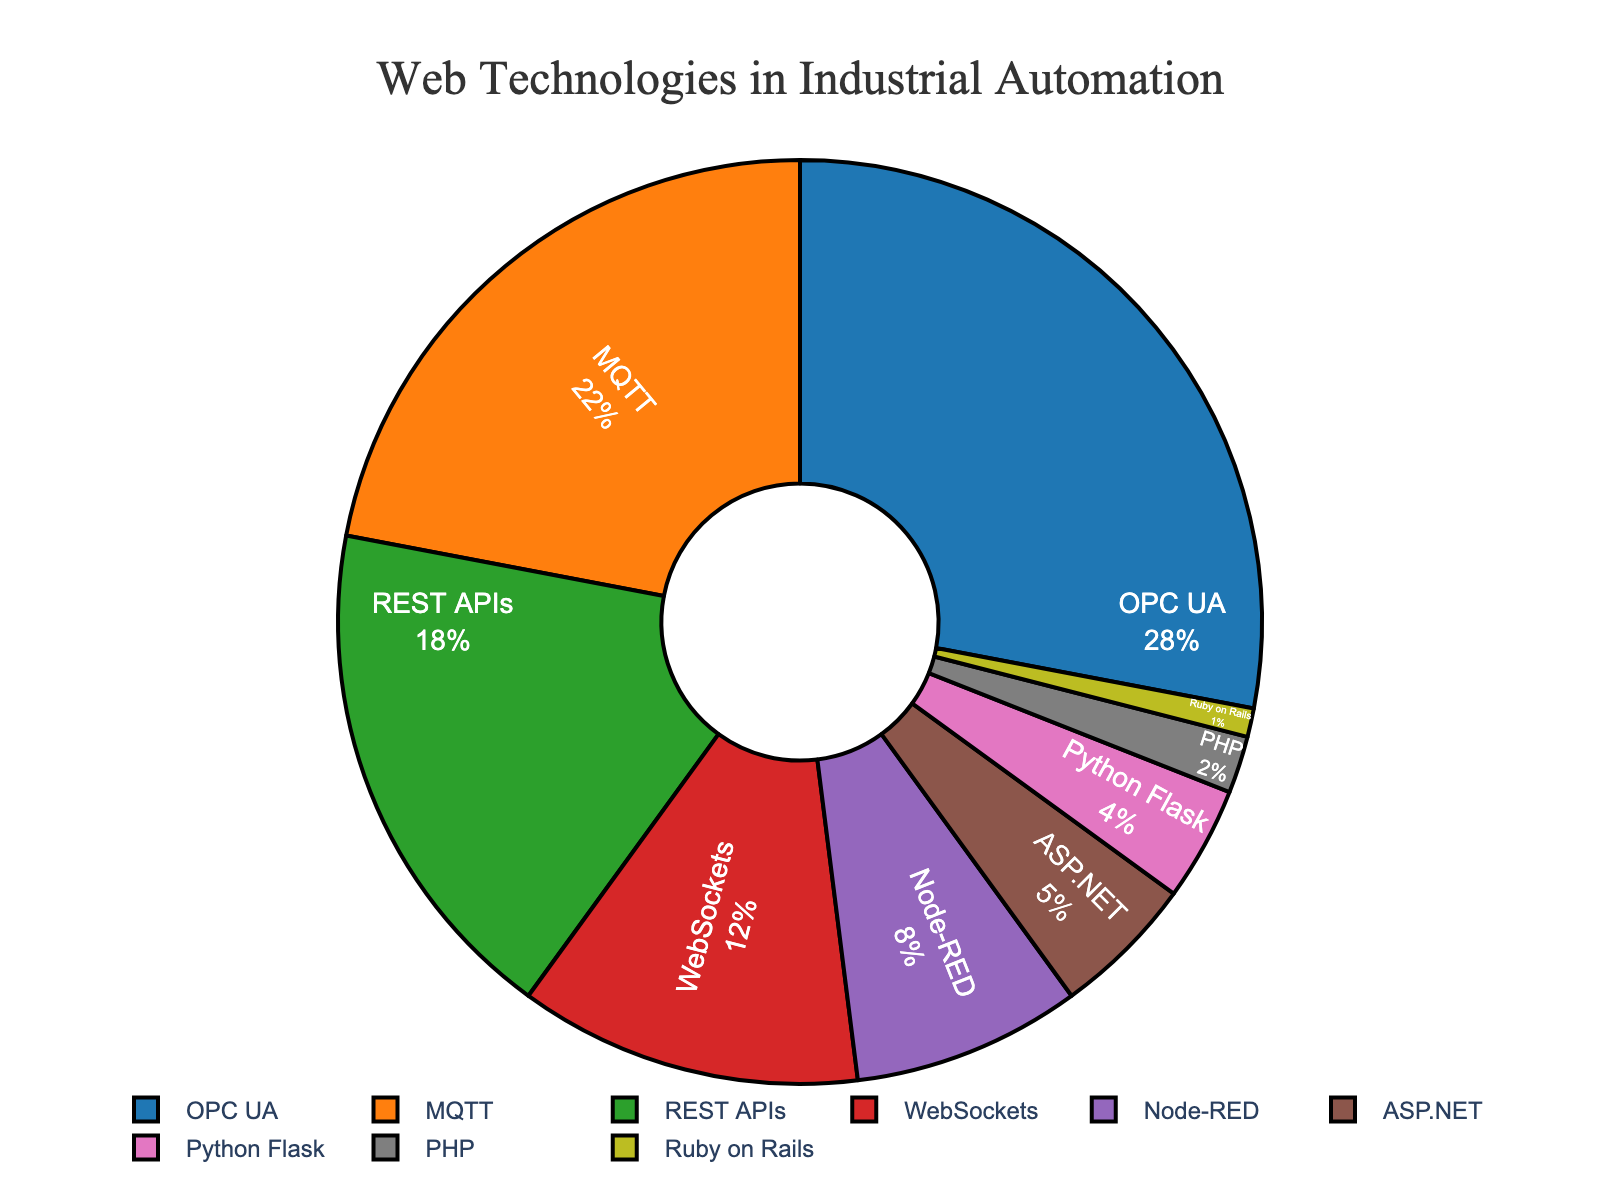What's the most adopted web technology in industrial automation? The pie chart shows that OPC UA has the largest segment, indicating it is the most adopted web technology.
Answer: OPC UA What is the combined adoption percentage of MQTT and REST APIs? According to the data, MQTT has an adoption percentage of 22%, and REST APIs have 18%. Adding these together, 22% + 18% = 40%.
Answer: 40% Which technology has a higher adoption rate: Node-RED or WebSockets? By comparing the segments, WebSockets have an adoption percentage of 12%, while Node-RED has 8%. Therefore, WebSockets are higher.
Answer: WebSockets What is the total percentage of adoption for technologies other than the top three (OPC UA, MQTT, and REST APIs)? The top three technologies (OPC UA, MQTT, REST APIs) have a combined adoption percentage of 28% + 22% + 18% = 68%. The total percentage for other technologies is 100% - 68% = 32%.
Answer: 32% What percentage of adoption does Python Flask have compared to ASP.NET? Python Flask has an adoption percentage of 4% and ASP.NET has 5%. To find the relative percentage of Python Flask compared to ASP.NET, calculate (4% / 5%) * 100 = 80%.
Answer: 80% Which segments in the pie chart are colored in green and purple, respectively? Observing the colors of the segments, the green segment represents REST APIs (18%), and the purple segment represents WebSockets (12%).
Answer: REST APIs and WebSockets How does the adoption of PHP compare to Ruby on Rails, and which one has the lesser adoption? Comparing the segments, PHP has an adoption percentage of 2%, and Ruby on Rails has 1%. Ruby on Rails has the lesser adoption.
Answer: Ruby on Rails What is the total adoption percentage for technologies with an adoption rate of 5% or less? Summing up the percentages for ASP.NET, Python Flask, PHP, and Ruby on Rails, we get 5% + 4% + 2% + 1% = 12%.
Answer: 12% How much larger is the adoption percentage of WebSockets compared to Ruby on Rails? WebSockets have an adoption percentage of 12%, while Ruby on Rails has 1%. The difference is 12% - 1% = 11%.
Answer: 11% What is the average adoption percentage for the top five technologies in the chart? The top five technologies are OPC UA (28%), MQTT (22%), REST APIs (18%), WebSockets (12%), and Node-RED (8%). Their average is (28% + 22% + 18% + 12% + 8%) / 5 = 88% / 5 = 17.6%.
Answer: 17.6% 